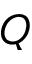<formula> <loc_0><loc_0><loc_500><loc_500>Q</formula> 